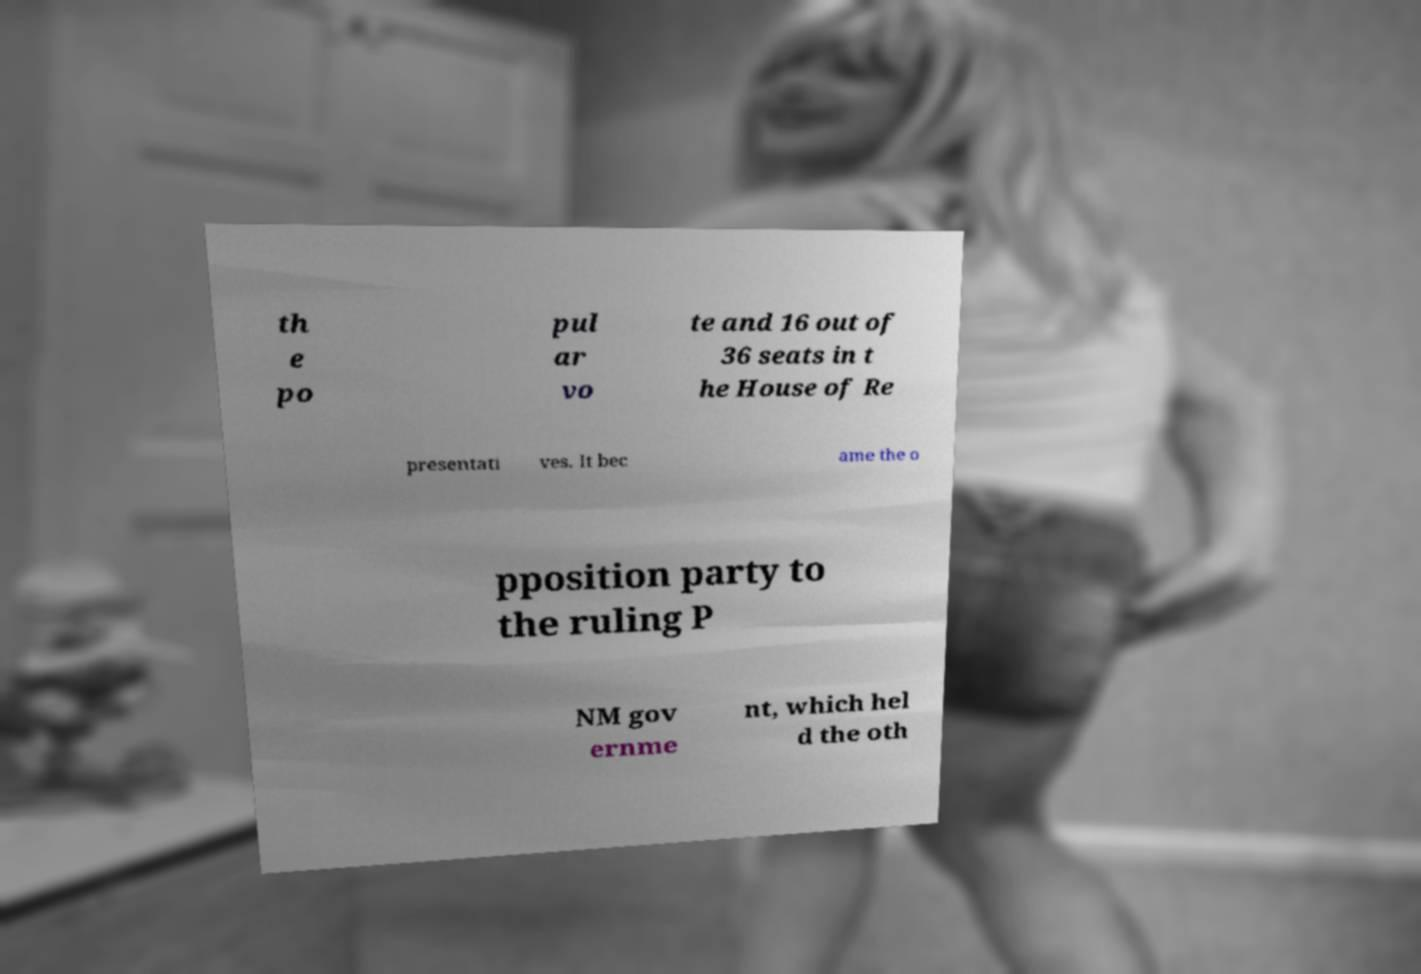For documentation purposes, I need the text within this image transcribed. Could you provide that? th e po pul ar vo te and 16 out of 36 seats in t he House of Re presentati ves. It bec ame the o pposition party to the ruling P NM gov ernme nt, which hel d the oth 